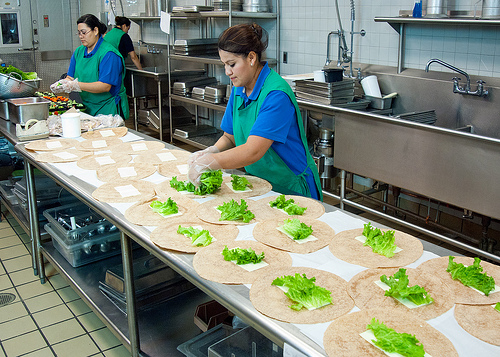Please provide a short description for this region: [0.38, 0.62, 0.58, 0.7]. Tortilla on a counter. Several tortillas are neatly aligned on the countertop, awaiting preparation into dishes. Each tortilla is perfectly round and appears fresh. 